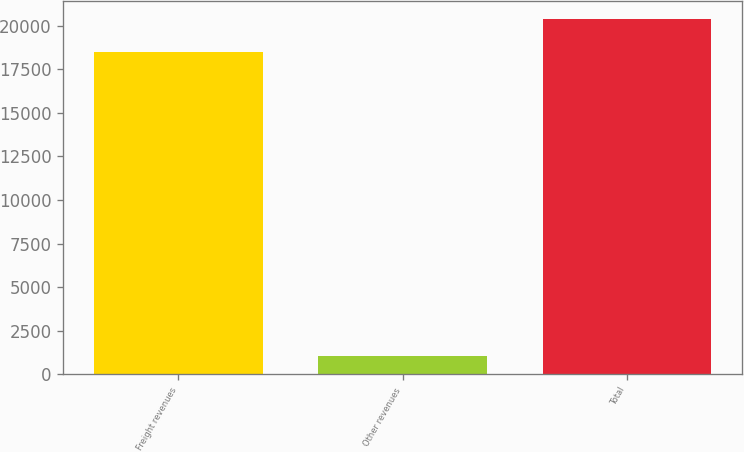<chart> <loc_0><loc_0><loc_500><loc_500><bar_chart><fcel>Freight revenues<fcel>Other revenues<fcel>Total<nl><fcel>18508<fcel>1049<fcel>20358.8<nl></chart> 